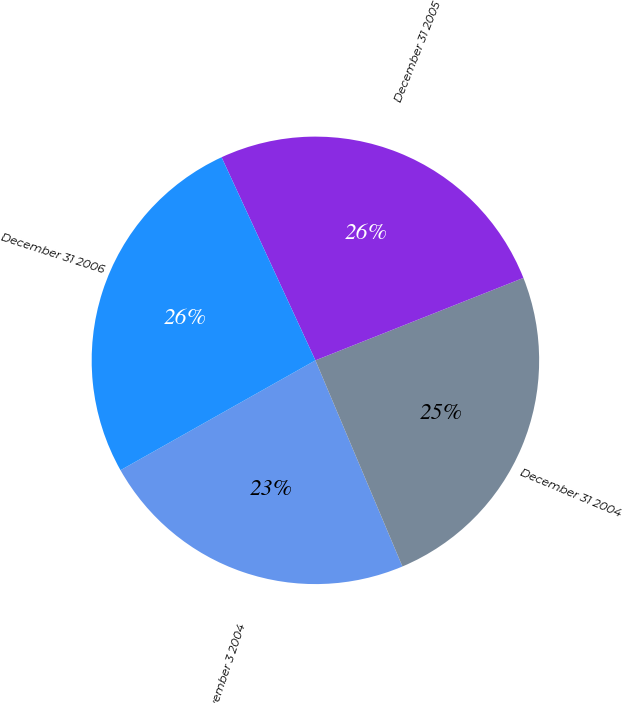Convert chart. <chart><loc_0><loc_0><loc_500><loc_500><pie_chart><fcel>November 3 2004<fcel>December 31 2004<fcel>December 31 2005<fcel>December 31 2006<nl><fcel>23.19%<fcel>24.65%<fcel>25.88%<fcel>26.28%<nl></chart> 